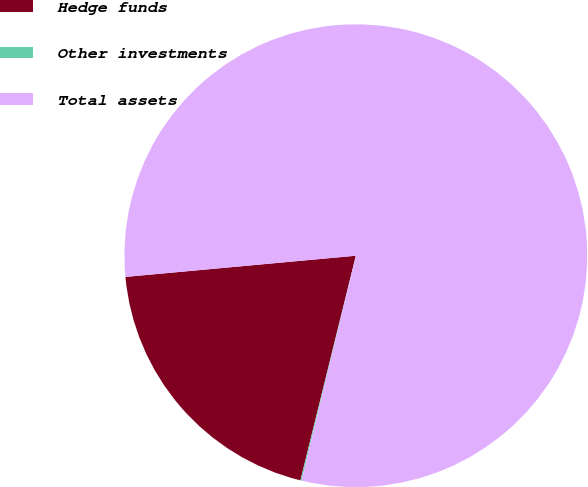Convert chart. <chart><loc_0><loc_0><loc_500><loc_500><pie_chart><fcel>Hedge funds<fcel>Other investments<fcel>Total assets<nl><fcel>19.69%<fcel>0.08%<fcel>80.23%<nl></chart> 